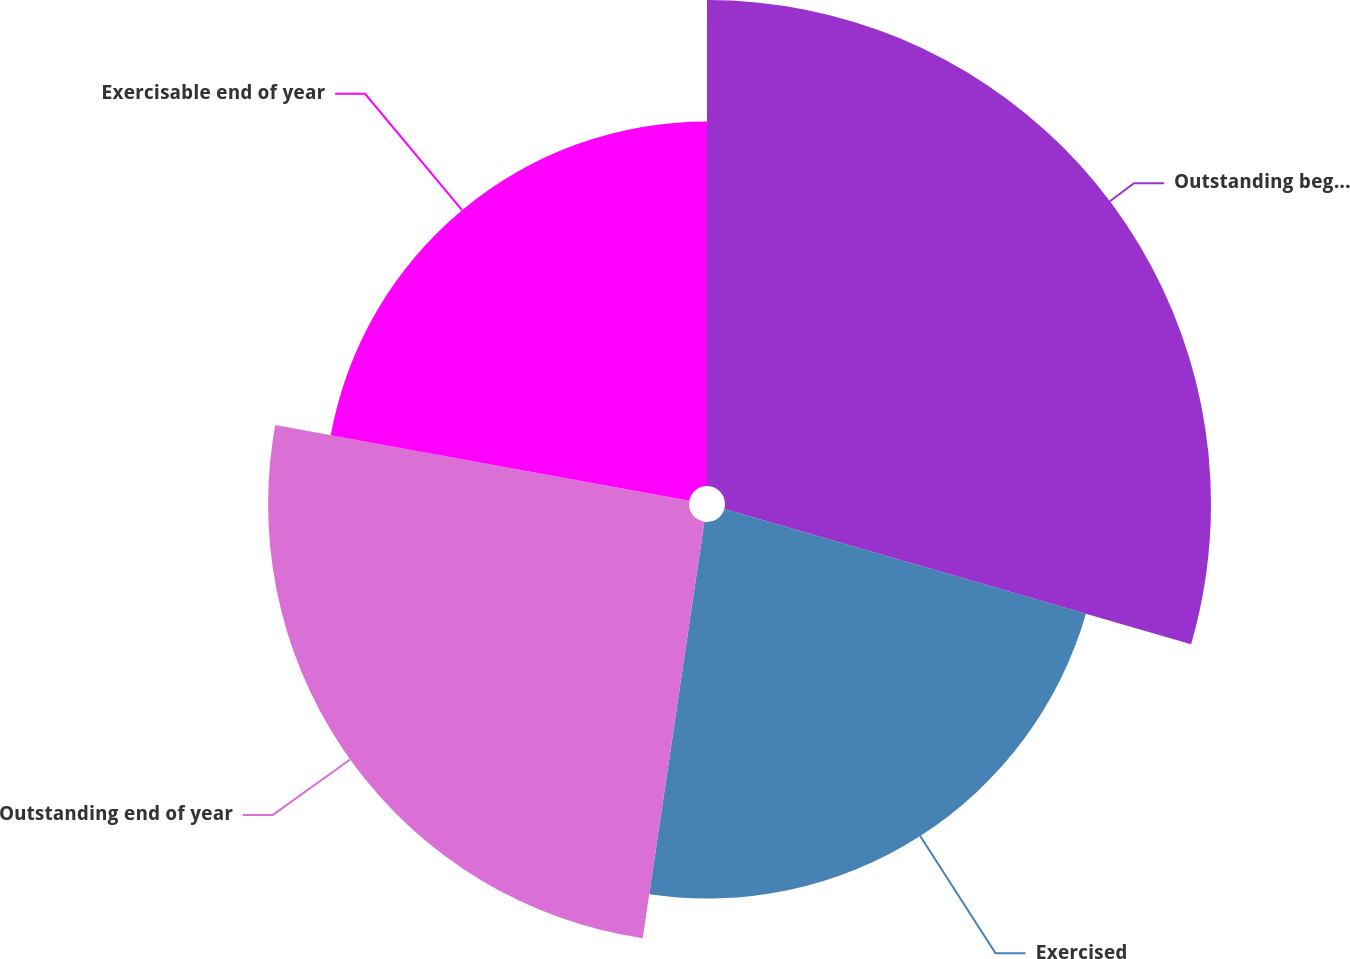Convert chart to OTSL. <chart><loc_0><loc_0><loc_500><loc_500><pie_chart><fcel>Outstanding beginning of year<fcel>Exercised<fcel>Outstanding end of year<fcel>Exercisable end of year<nl><fcel>29.49%<fcel>22.85%<fcel>25.54%<fcel>22.12%<nl></chart> 